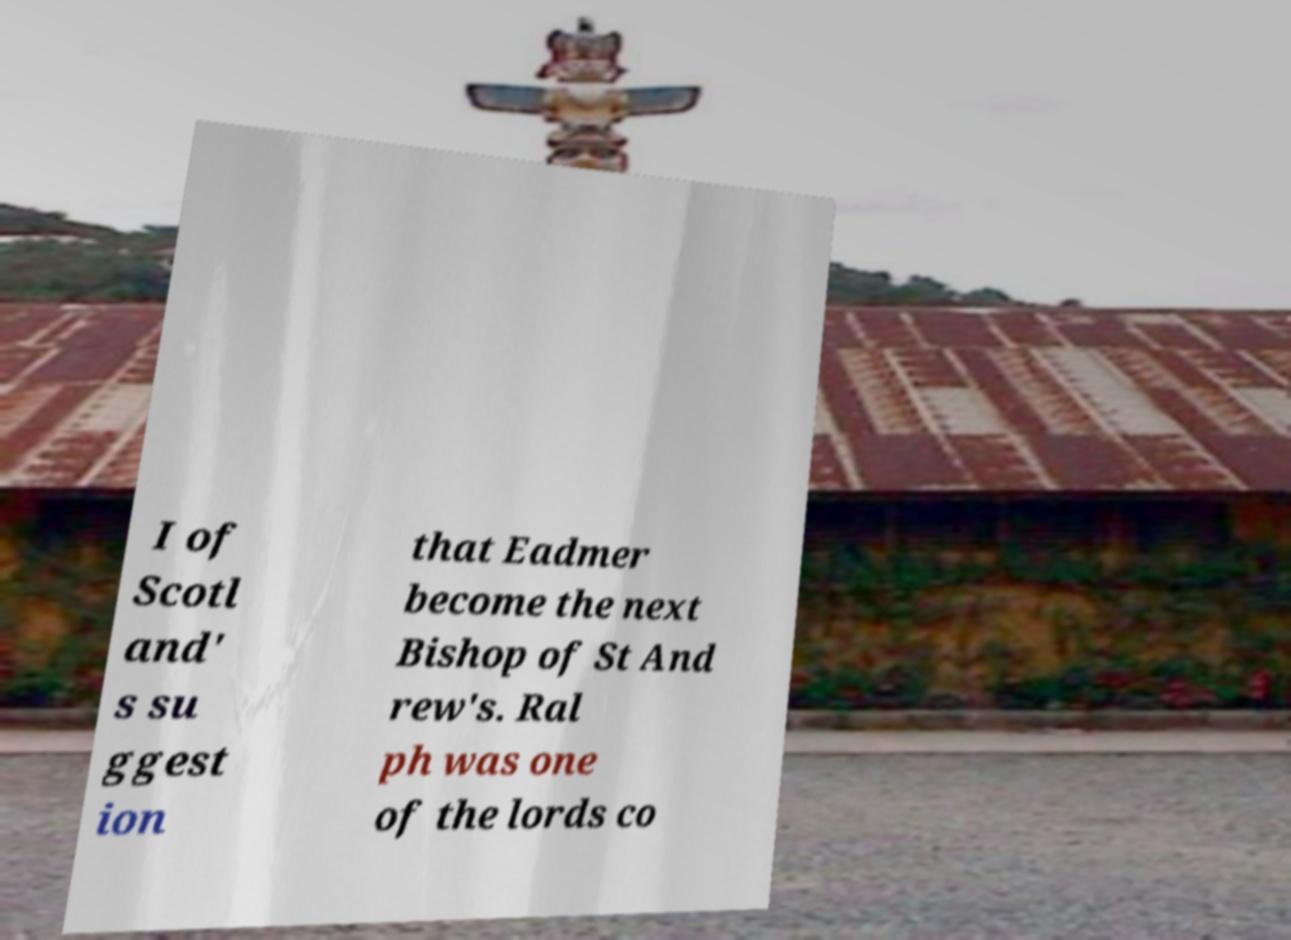Can you read and provide the text displayed in the image?This photo seems to have some interesting text. Can you extract and type it out for me? I of Scotl and' s su ggest ion that Eadmer become the next Bishop of St And rew's. Ral ph was one of the lords co 